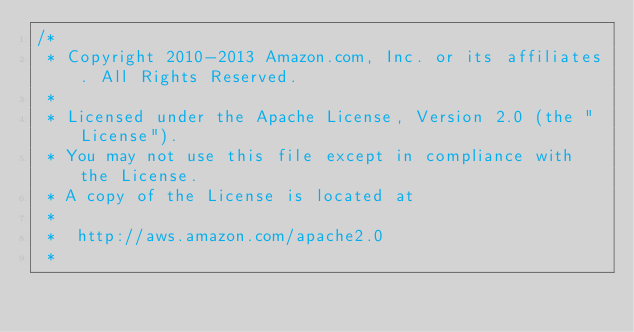Convert code to text. <code><loc_0><loc_0><loc_500><loc_500><_C_>/*
 * Copyright 2010-2013 Amazon.com, Inc. or its affiliates. All Rights Reserved.
 *
 * Licensed under the Apache License, Version 2.0 (the "License").
 * You may not use this file except in compliance with the License.
 * A copy of the License is located at
 *
 *  http://aws.amazon.com/apache2.0
 *</code> 